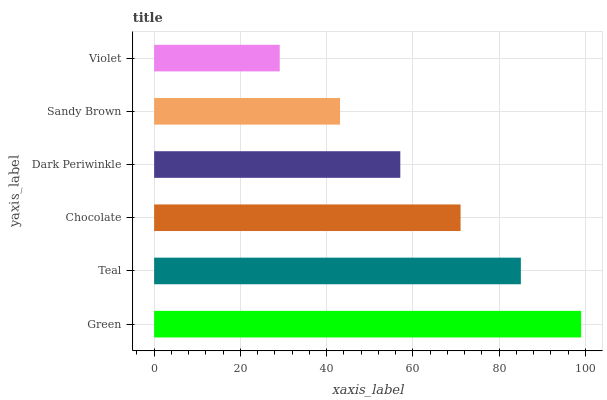Is Violet the minimum?
Answer yes or no. Yes. Is Green the maximum?
Answer yes or no. Yes. Is Teal the minimum?
Answer yes or no. No. Is Teal the maximum?
Answer yes or no. No. Is Green greater than Teal?
Answer yes or no. Yes. Is Teal less than Green?
Answer yes or no. Yes. Is Teal greater than Green?
Answer yes or no. No. Is Green less than Teal?
Answer yes or no. No. Is Chocolate the high median?
Answer yes or no. Yes. Is Dark Periwinkle the low median?
Answer yes or no. Yes. Is Violet the high median?
Answer yes or no. No. Is Teal the low median?
Answer yes or no. No. 